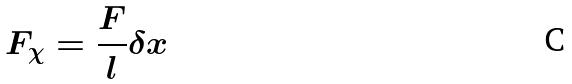Convert formula to latex. <formula><loc_0><loc_0><loc_500><loc_500>F _ { \chi } = \frac { F } { l } \delta x</formula> 